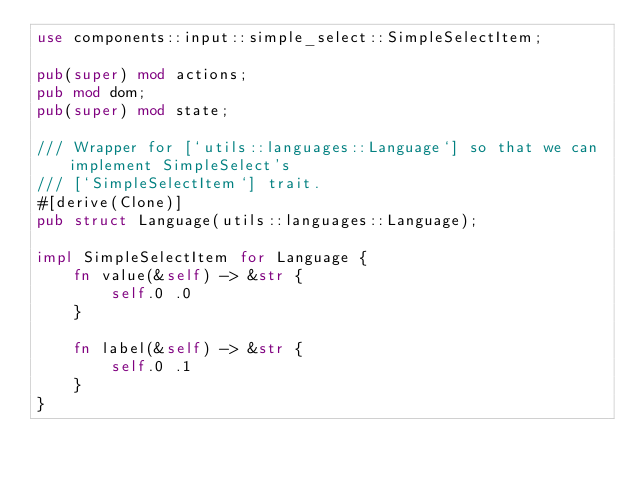<code> <loc_0><loc_0><loc_500><loc_500><_Rust_>use components::input::simple_select::SimpleSelectItem;

pub(super) mod actions;
pub mod dom;
pub(super) mod state;

/// Wrapper for [`utils::languages::Language`] so that we can implement SimpleSelect's
/// [`SimpleSelectItem`] trait.
#[derive(Clone)]
pub struct Language(utils::languages::Language);

impl SimpleSelectItem for Language {
    fn value(&self) -> &str {
        self.0 .0
    }

    fn label(&self) -> &str {
        self.0 .1
    }
}
</code> 